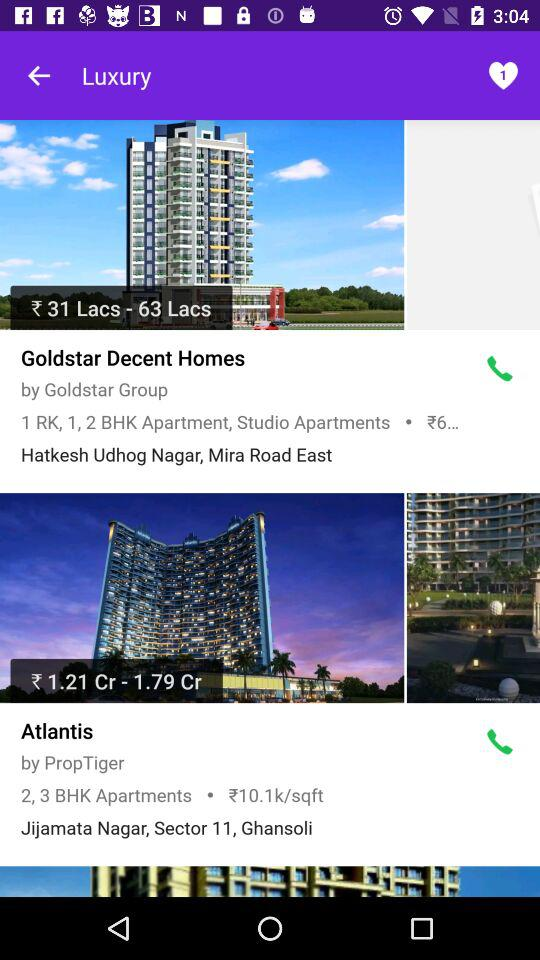What is the name of the construction group for "Atlantis"? The name of the construction group is "PropTiger". 